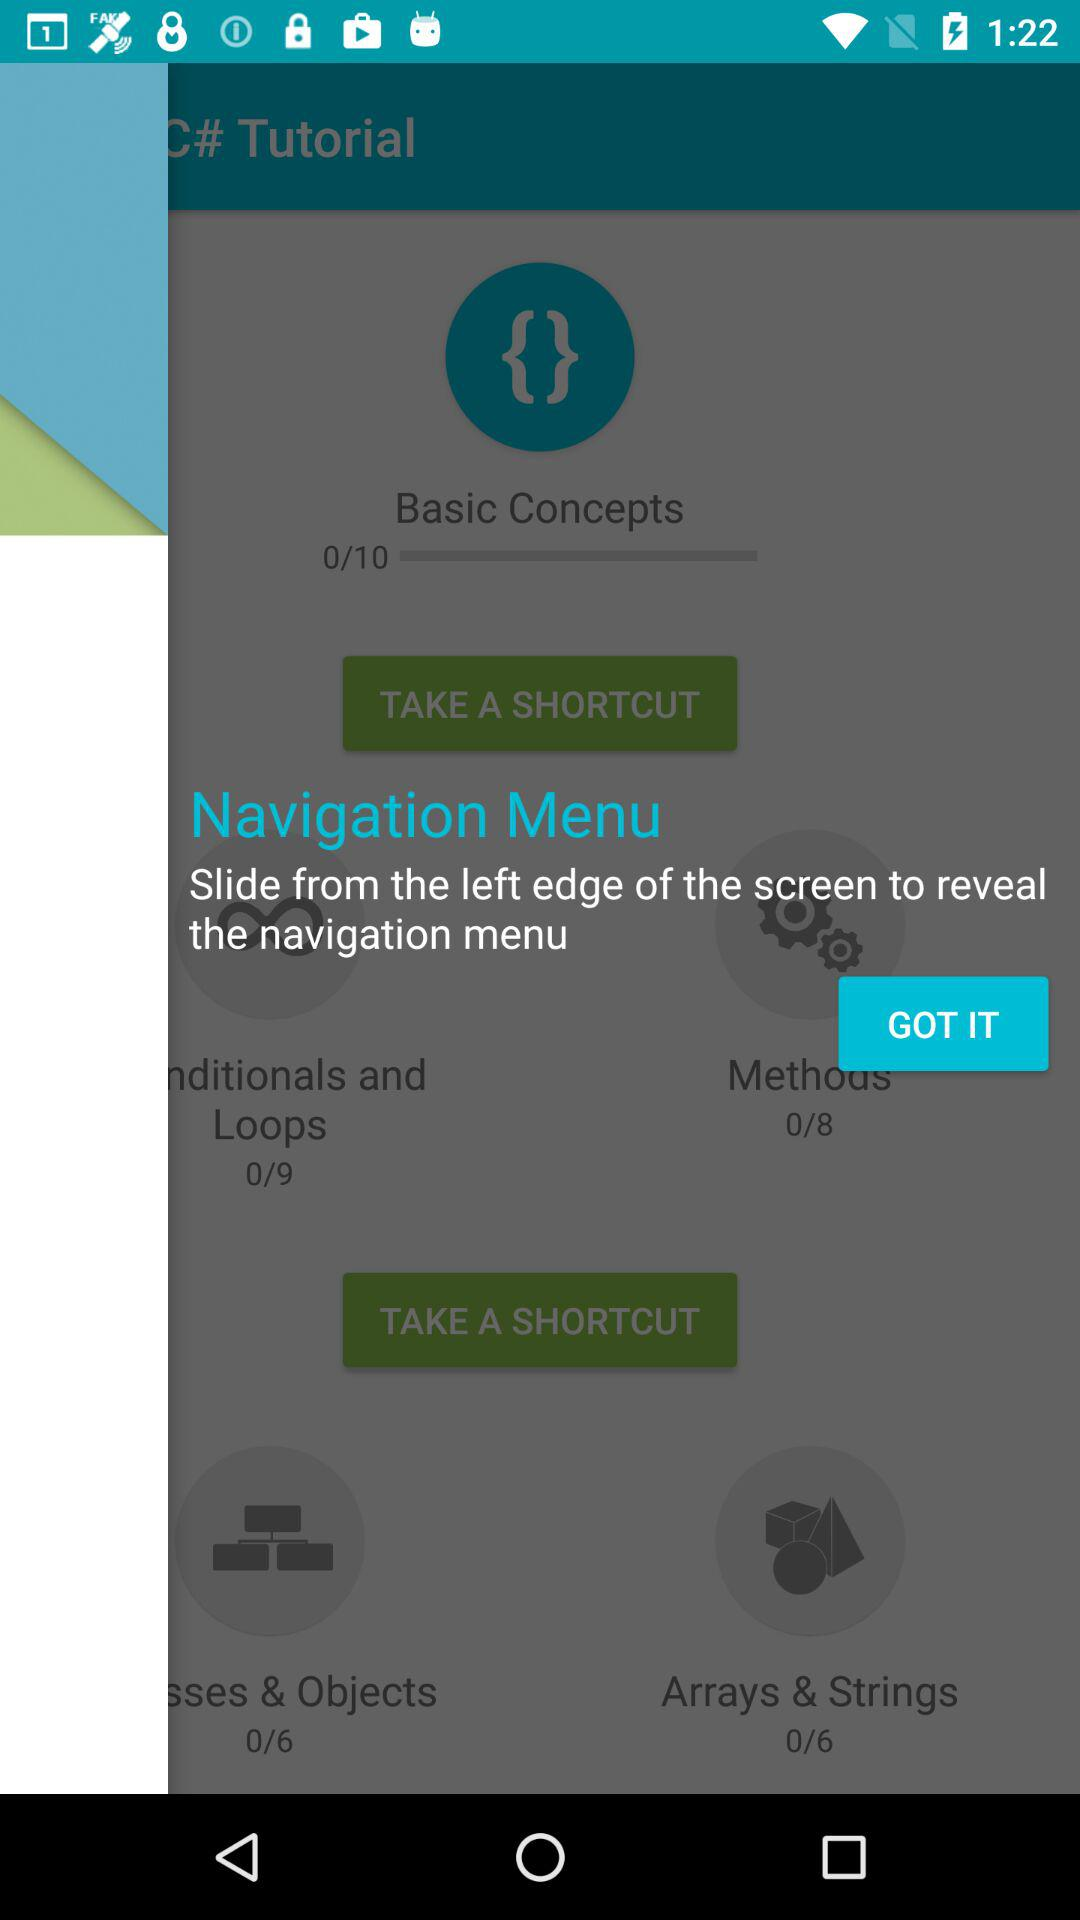How many lessons do you have to complete to unlock the 'Methods' section?
Answer the question using a single word or phrase. 8 